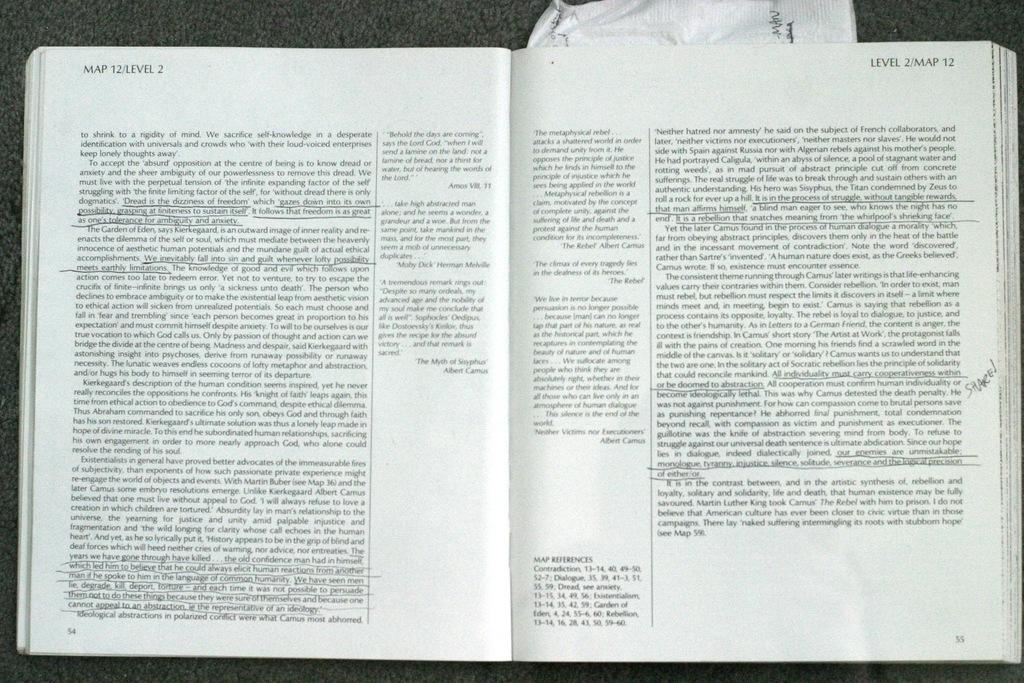What level is this book on?
Provide a succinct answer. 2. 